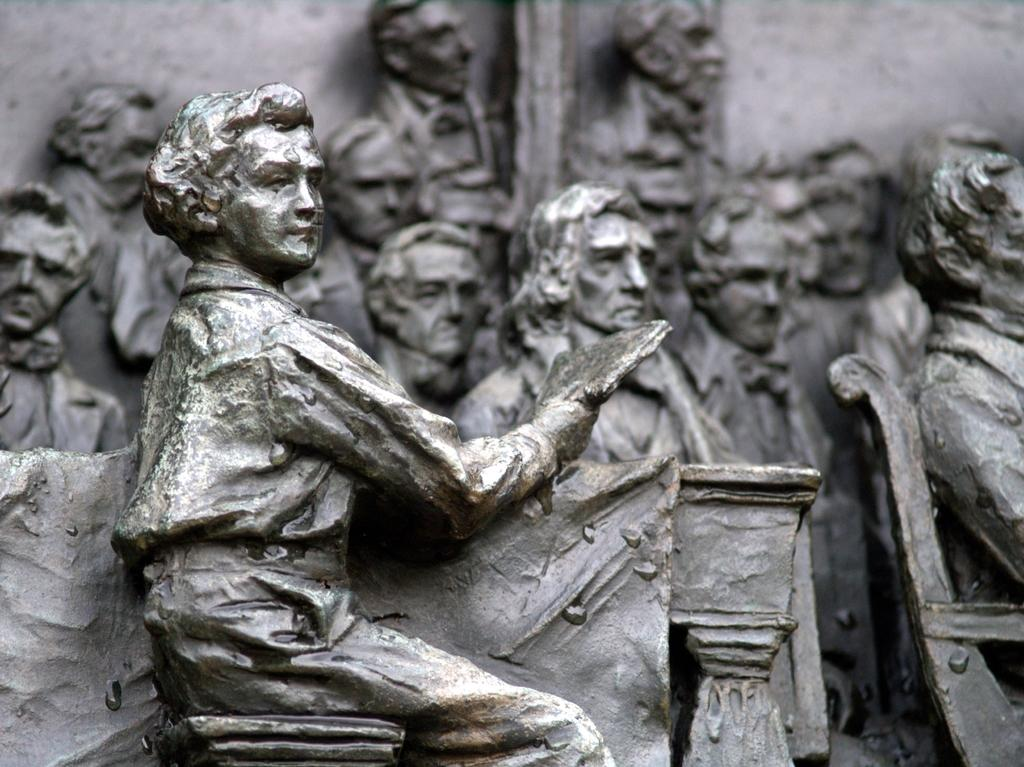What type of objects are depicted in the image? There are sculptures of people in the image. Are there any furniture items in the image? Yes, there is a chair in the image. Can you describe any other objects present in the image? There are other unspecified objects in the image. What type of mask is the stranger wearing in the image? There is no stranger or mask present in the image; it features sculptures of people and a chair. What type of lace is used to decorate the sculptures in the image? There is no lace present in the image; the sculptures are made of unspecified material. 